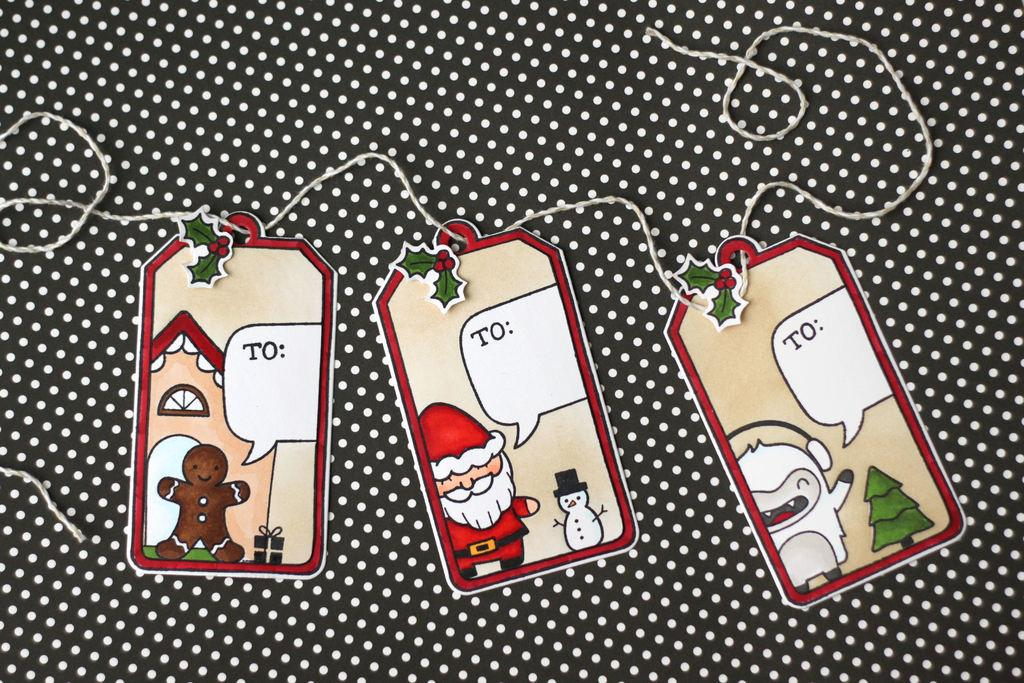What can be seen in the image related to identification or labeling? There are tags in the image. What material is featured in the image that might be used for sewing or stitching? There is a thread on a cloth in the image. What type of education is being provided in the image? There is no indication of education in the image; it only features tags and a thread on a cloth. How does the image demonstrate respect for a particular culture or tradition? The image does not demonstrate respect for a particular culture or tradition; it only features tags and a thread on a cloth. 